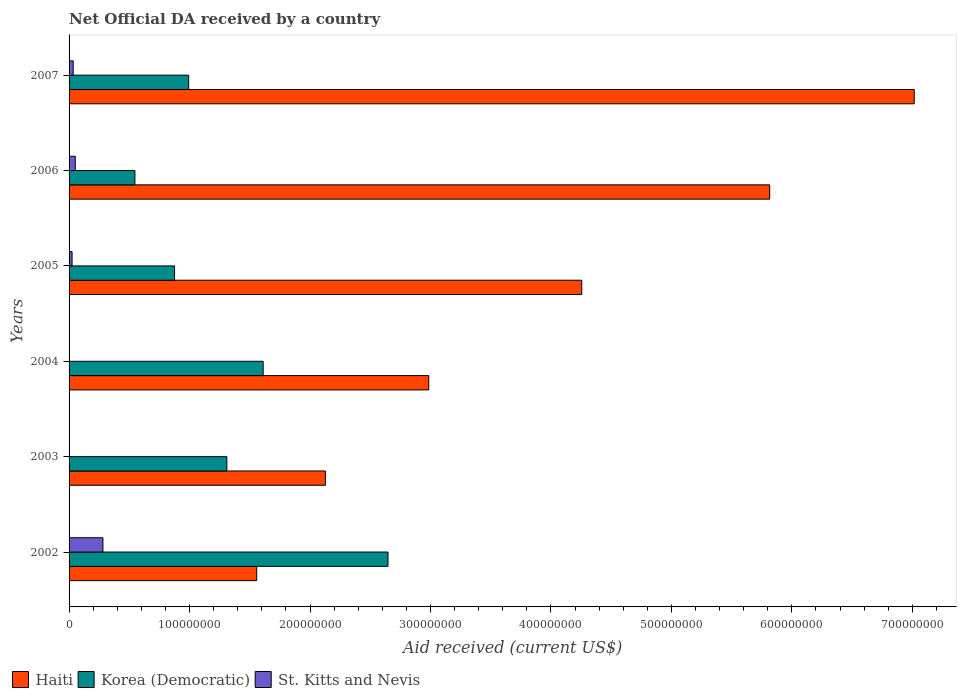How many groups of bars are there?
Your answer should be compact. 6. Are the number of bars per tick equal to the number of legend labels?
Provide a short and direct response. Yes. How many bars are there on the 5th tick from the top?
Provide a short and direct response. 3. What is the label of the 2nd group of bars from the top?
Make the answer very short. 2006. In how many cases, is the number of bars for a given year not equal to the number of legend labels?
Ensure brevity in your answer.  0. What is the net official development assistance aid received in Korea (Democratic) in 2003?
Make the answer very short. 1.31e+08. Across all years, what is the maximum net official development assistance aid received in Haiti?
Your answer should be very brief. 7.02e+08. Across all years, what is the minimum net official development assistance aid received in Korea (Democratic)?
Offer a very short reply. 5.46e+07. In which year was the net official development assistance aid received in Korea (Democratic) minimum?
Offer a very short reply. 2006. What is the total net official development assistance aid received in St. Kitts and Nevis in the graph?
Your response must be concise. 3.94e+07. What is the difference between the net official development assistance aid received in St. Kitts and Nevis in 2002 and that in 2003?
Keep it short and to the point. 2.79e+07. What is the difference between the net official development assistance aid received in Haiti in 2006 and the net official development assistance aid received in St. Kitts and Nevis in 2005?
Ensure brevity in your answer.  5.79e+08. What is the average net official development assistance aid received in Korea (Democratic) per year?
Give a very brief answer. 1.33e+08. In the year 2006, what is the difference between the net official development assistance aid received in St. Kitts and Nevis and net official development assistance aid received in Korea (Democratic)?
Your response must be concise. -4.95e+07. In how many years, is the net official development assistance aid received in Haiti greater than 400000000 US$?
Your answer should be very brief. 3. What is the ratio of the net official development assistance aid received in Haiti in 2002 to that in 2006?
Provide a short and direct response. 0.27. What is the difference between the highest and the second highest net official development assistance aid received in Korea (Democratic)?
Your answer should be very brief. 1.04e+08. What is the difference between the highest and the lowest net official development assistance aid received in Haiti?
Your answer should be very brief. 5.46e+08. What does the 2nd bar from the top in 2007 represents?
Give a very brief answer. Korea (Democratic). What does the 1st bar from the bottom in 2007 represents?
Your answer should be very brief. Haiti. Is it the case that in every year, the sum of the net official development assistance aid received in St. Kitts and Nevis and net official development assistance aid received in Haiti is greater than the net official development assistance aid received in Korea (Democratic)?
Offer a terse response. No. What is the difference between two consecutive major ticks on the X-axis?
Give a very brief answer. 1.00e+08. Are the values on the major ticks of X-axis written in scientific E-notation?
Ensure brevity in your answer.  No. Where does the legend appear in the graph?
Offer a terse response. Bottom left. What is the title of the graph?
Your response must be concise. Net Official DA received by a country. Does "Burundi" appear as one of the legend labels in the graph?
Your answer should be compact. No. What is the label or title of the X-axis?
Offer a terse response. Aid received (current US$). What is the label or title of the Y-axis?
Make the answer very short. Years. What is the Aid received (current US$) of Haiti in 2002?
Offer a terse response. 1.56e+08. What is the Aid received (current US$) of Korea (Democratic) in 2002?
Provide a succinct answer. 2.65e+08. What is the Aid received (current US$) of St. Kitts and Nevis in 2002?
Provide a short and direct response. 2.81e+07. What is the Aid received (current US$) in Haiti in 2003?
Provide a succinct answer. 2.13e+08. What is the Aid received (current US$) of Korea (Democratic) in 2003?
Your response must be concise. 1.31e+08. What is the Aid received (current US$) of Haiti in 2004?
Ensure brevity in your answer.  2.99e+08. What is the Aid received (current US$) in Korea (Democratic) in 2004?
Provide a short and direct response. 1.61e+08. What is the Aid received (current US$) in Haiti in 2005?
Your answer should be very brief. 4.26e+08. What is the Aid received (current US$) in Korea (Democratic) in 2005?
Make the answer very short. 8.76e+07. What is the Aid received (current US$) in St. Kitts and Nevis in 2005?
Provide a short and direct response. 2.50e+06. What is the Aid received (current US$) in Haiti in 2006?
Your answer should be compact. 5.82e+08. What is the Aid received (current US$) of Korea (Democratic) in 2006?
Give a very brief answer. 5.46e+07. What is the Aid received (current US$) in St. Kitts and Nevis in 2006?
Your response must be concise. 5.16e+06. What is the Aid received (current US$) in Haiti in 2007?
Keep it short and to the point. 7.02e+08. What is the Aid received (current US$) of Korea (Democratic) in 2007?
Offer a very short reply. 9.93e+07. What is the Aid received (current US$) in St. Kitts and Nevis in 2007?
Make the answer very short. 3.44e+06. Across all years, what is the maximum Aid received (current US$) of Haiti?
Your answer should be compact. 7.02e+08. Across all years, what is the maximum Aid received (current US$) in Korea (Democratic)?
Keep it short and to the point. 2.65e+08. Across all years, what is the maximum Aid received (current US$) of St. Kitts and Nevis?
Provide a short and direct response. 2.81e+07. Across all years, what is the minimum Aid received (current US$) in Haiti?
Give a very brief answer. 1.56e+08. Across all years, what is the minimum Aid received (current US$) in Korea (Democratic)?
Offer a very short reply. 5.46e+07. Across all years, what is the minimum Aid received (current US$) in St. Kitts and Nevis?
Give a very brief answer. 4.00e+04. What is the total Aid received (current US$) in Haiti in the graph?
Provide a short and direct response. 2.38e+09. What is the total Aid received (current US$) of Korea (Democratic) in the graph?
Provide a short and direct response. 7.98e+08. What is the total Aid received (current US$) in St. Kitts and Nevis in the graph?
Ensure brevity in your answer.  3.94e+07. What is the difference between the Aid received (current US$) in Haiti in 2002 and that in 2003?
Your answer should be compact. -5.70e+07. What is the difference between the Aid received (current US$) of Korea (Democratic) in 2002 and that in 2003?
Give a very brief answer. 1.34e+08. What is the difference between the Aid received (current US$) of St. Kitts and Nevis in 2002 and that in 2003?
Offer a very short reply. 2.79e+07. What is the difference between the Aid received (current US$) in Haiti in 2002 and that in 2004?
Your response must be concise. -1.43e+08. What is the difference between the Aid received (current US$) in Korea (Democratic) in 2002 and that in 2004?
Make the answer very short. 1.04e+08. What is the difference between the Aid received (current US$) of St. Kitts and Nevis in 2002 and that in 2004?
Your response must be concise. 2.81e+07. What is the difference between the Aid received (current US$) of Haiti in 2002 and that in 2005?
Provide a succinct answer. -2.70e+08. What is the difference between the Aid received (current US$) of Korea (Democratic) in 2002 and that in 2005?
Provide a succinct answer. 1.77e+08. What is the difference between the Aid received (current US$) in St. Kitts and Nevis in 2002 and that in 2005?
Ensure brevity in your answer.  2.56e+07. What is the difference between the Aid received (current US$) in Haiti in 2002 and that in 2006?
Make the answer very short. -4.26e+08. What is the difference between the Aid received (current US$) of Korea (Democratic) in 2002 and that in 2006?
Provide a short and direct response. 2.10e+08. What is the difference between the Aid received (current US$) in St. Kitts and Nevis in 2002 and that in 2006?
Your answer should be compact. 2.29e+07. What is the difference between the Aid received (current US$) in Haiti in 2002 and that in 2007?
Keep it short and to the point. -5.46e+08. What is the difference between the Aid received (current US$) of Korea (Democratic) in 2002 and that in 2007?
Make the answer very short. 1.65e+08. What is the difference between the Aid received (current US$) of St. Kitts and Nevis in 2002 and that in 2007?
Provide a succinct answer. 2.47e+07. What is the difference between the Aid received (current US$) of Haiti in 2003 and that in 2004?
Your answer should be very brief. -8.58e+07. What is the difference between the Aid received (current US$) of Korea (Democratic) in 2003 and that in 2004?
Your answer should be compact. -3.01e+07. What is the difference between the Aid received (current US$) of St. Kitts and Nevis in 2003 and that in 2004?
Provide a short and direct response. 1.20e+05. What is the difference between the Aid received (current US$) in Haiti in 2003 and that in 2005?
Offer a terse response. -2.13e+08. What is the difference between the Aid received (current US$) of Korea (Democratic) in 2003 and that in 2005?
Your answer should be very brief. 4.34e+07. What is the difference between the Aid received (current US$) in St. Kitts and Nevis in 2003 and that in 2005?
Ensure brevity in your answer.  -2.34e+06. What is the difference between the Aid received (current US$) in Haiti in 2003 and that in 2006?
Give a very brief answer. -3.69e+08. What is the difference between the Aid received (current US$) of Korea (Democratic) in 2003 and that in 2006?
Ensure brevity in your answer.  7.63e+07. What is the difference between the Aid received (current US$) of St. Kitts and Nevis in 2003 and that in 2006?
Offer a very short reply. -5.00e+06. What is the difference between the Aid received (current US$) of Haiti in 2003 and that in 2007?
Provide a succinct answer. -4.89e+08. What is the difference between the Aid received (current US$) of Korea (Democratic) in 2003 and that in 2007?
Offer a terse response. 3.17e+07. What is the difference between the Aid received (current US$) in St. Kitts and Nevis in 2003 and that in 2007?
Give a very brief answer. -3.28e+06. What is the difference between the Aid received (current US$) of Haiti in 2004 and that in 2005?
Provide a succinct answer. -1.27e+08. What is the difference between the Aid received (current US$) in Korea (Democratic) in 2004 and that in 2005?
Offer a terse response. 7.36e+07. What is the difference between the Aid received (current US$) in St. Kitts and Nevis in 2004 and that in 2005?
Ensure brevity in your answer.  -2.46e+06. What is the difference between the Aid received (current US$) in Haiti in 2004 and that in 2006?
Ensure brevity in your answer.  -2.83e+08. What is the difference between the Aid received (current US$) of Korea (Democratic) in 2004 and that in 2006?
Provide a succinct answer. 1.06e+08. What is the difference between the Aid received (current US$) of St. Kitts and Nevis in 2004 and that in 2006?
Your answer should be compact. -5.12e+06. What is the difference between the Aid received (current US$) of Haiti in 2004 and that in 2007?
Keep it short and to the point. -4.03e+08. What is the difference between the Aid received (current US$) of Korea (Democratic) in 2004 and that in 2007?
Your response must be concise. 6.18e+07. What is the difference between the Aid received (current US$) of St. Kitts and Nevis in 2004 and that in 2007?
Your answer should be compact. -3.40e+06. What is the difference between the Aid received (current US$) in Haiti in 2005 and that in 2006?
Ensure brevity in your answer.  -1.56e+08. What is the difference between the Aid received (current US$) of Korea (Democratic) in 2005 and that in 2006?
Ensure brevity in your answer.  3.29e+07. What is the difference between the Aid received (current US$) of St. Kitts and Nevis in 2005 and that in 2006?
Your response must be concise. -2.66e+06. What is the difference between the Aid received (current US$) of Haiti in 2005 and that in 2007?
Ensure brevity in your answer.  -2.76e+08. What is the difference between the Aid received (current US$) in Korea (Democratic) in 2005 and that in 2007?
Provide a short and direct response. -1.17e+07. What is the difference between the Aid received (current US$) in St. Kitts and Nevis in 2005 and that in 2007?
Offer a terse response. -9.40e+05. What is the difference between the Aid received (current US$) of Haiti in 2006 and that in 2007?
Offer a very short reply. -1.20e+08. What is the difference between the Aid received (current US$) of Korea (Democratic) in 2006 and that in 2007?
Give a very brief answer. -4.46e+07. What is the difference between the Aid received (current US$) in St. Kitts and Nevis in 2006 and that in 2007?
Make the answer very short. 1.72e+06. What is the difference between the Aid received (current US$) of Haiti in 2002 and the Aid received (current US$) of Korea (Democratic) in 2003?
Offer a terse response. 2.48e+07. What is the difference between the Aid received (current US$) in Haiti in 2002 and the Aid received (current US$) in St. Kitts and Nevis in 2003?
Your answer should be compact. 1.56e+08. What is the difference between the Aid received (current US$) in Korea (Democratic) in 2002 and the Aid received (current US$) in St. Kitts and Nevis in 2003?
Your answer should be compact. 2.65e+08. What is the difference between the Aid received (current US$) in Haiti in 2002 and the Aid received (current US$) in Korea (Democratic) in 2004?
Your answer should be very brief. -5.36e+06. What is the difference between the Aid received (current US$) in Haiti in 2002 and the Aid received (current US$) in St. Kitts and Nevis in 2004?
Provide a short and direct response. 1.56e+08. What is the difference between the Aid received (current US$) of Korea (Democratic) in 2002 and the Aid received (current US$) of St. Kitts and Nevis in 2004?
Offer a terse response. 2.65e+08. What is the difference between the Aid received (current US$) in Haiti in 2002 and the Aid received (current US$) in Korea (Democratic) in 2005?
Offer a terse response. 6.82e+07. What is the difference between the Aid received (current US$) of Haiti in 2002 and the Aid received (current US$) of St. Kitts and Nevis in 2005?
Provide a succinct answer. 1.53e+08. What is the difference between the Aid received (current US$) in Korea (Democratic) in 2002 and the Aid received (current US$) in St. Kitts and Nevis in 2005?
Provide a succinct answer. 2.62e+08. What is the difference between the Aid received (current US$) in Haiti in 2002 and the Aid received (current US$) in Korea (Democratic) in 2006?
Make the answer very short. 1.01e+08. What is the difference between the Aid received (current US$) of Haiti in 2002 and the Aid received (current US$) of St. Kitts and Nevis in 2006?
Your response must be concise. 1.51e+08. What is the difference between the Aid received (current US$) of Korea (Democratic) in 2002 and the Aid received (current US$) of St. Kitts and Nevis in 2006?
Give a very brief answer. 2.60e+08. What is the difference between the Aid received (current US$) in Haiti in 2002 and the Aid received (current US$) in Korea (Democratic) in 2007?
Provide a short and direct response. 5.65e+07. What is the difference between the Aid received (current US$) in Haiti in 2002 and the Aid received (current US$) in St. Kitts and Nevis in 2007?
Your answer should be very brief. 1.52e+08. What is the difference between the Aid received (current US$) in Korea (Democratic) in 2002 and the Aid received (current US$) in St. Kitts and Nevis in 2007?
Your response must be concise. 2.61e+08. What is the difference between the Aid received (current US$) of Haiti in 2003 and the Aid received (current US$) of Korea (Democratic) in 2004?
Provide a succinct answer. 5.16e+07. What is the difference between the Aid received (current US$) of Haiti in 2003 and the Aid received (current US$) of St. Kitts and Nevis in 2004?
Offer a very short reply. 2.13e+08. What is the difference between the Aid received (current US$) in Korea (Democratic) in 2003 and the Aid received (current US$) in St. Kitts and Nevis in 2004?
Your answer should be compact. 1.31e+08. What is the difference between the Aid received (current US$) in Haiti in 2003 and the Aid received (current US$) in Korea (Democratic) in 2005?
Ensure brevity in your answer.  1.25e+08. What is the difference between the Aid received (current US$) of Haiti in 2003 and the Aid received (current US$) of St. Kitts and Nevis in 2005?
Provide a succinct answer. 2.10e+08. What is the difference between the Aid received (current US$) in Korea (Democratic) in 2003 and the Aid received (current US$) in St. Kitts and Nevis in 2005?
Keep it short and to the point. 1.28e+08. What is the difference between the Aid received (current US$) of Haiti in 2003 and the Aid received (current US$) of Korea (Democratic) in 2006?
Provide a succinct answer. 1.58e+08. What is the difference between the Aid received (current US$) of Haiti in 2003 and the Aid received (current US$) of St. Kitts and Nevis in 2006?
Offer a terse response. 2.08e+08. What is the difference between the Aid received (current US$) of Korea (Democratic) in 2003 and the Aid received (current US$) of St. Kitts and Nevis in 2006?
Your response must be concise. 1.26e+08. What is the difference between the Aid received (current US$) in Haiti in 2003 and the Aid received (current US$) in Korea (Democratic) in 2007?
Offer a terse response. 1.13e+08. What is the difference between the Aid received (current US$) of Haiti in 2003 and the Aid received (current US$) of St. Kitts and Nevis in 2007?
Ensure brevity in your answer.  2.09e+08. What is the difference between the Aid received (current US$) in Korea (Democratic) in 2003 and the Aid received (current US$) in St. Kitts and Nevis in 2007?
Your response must be concise. 1.28e+08. What is the difference between the Aid received (current US$) of Haiti in 2004 and the Aid received (current US$) of Korea (Democratic) in 2005?
Provide a succinct answer. 2.11e+08. What is the difference between the Aid received (current US$) in Haiti in 2004 and the Aid received (current US$) in St. Kitts and Nevis in 2005?
Provide a short and direct response. 2.96e+08. What is the difference between the Aid received (current US$) of Korea (Democratic) in 2004 and the Aid received (current US$) of St. Kitts and Nevis in 2005?
Give a very brief answer. 1.59e+08. What is the difference between the Aid received (current US$) in Haiti in 2004 and the Aid received (current US$) in Korea (Democratic) in 2006?
Give a very brief answer. 2.44e+08. What is the difference between the Aid received (current US$) in Haiti in 2004 and the Aid received (current US$) in St. Kitts and Nevis in 2006?
Provide a short and direct response. 2.93e+08. What is the difference between the Aid received (current US$) of Korea (Democratic) in 2004 and the Aid received (current US$) of St. Kitts and Nevis in 2006?
Your answer should be compact. 1.56e+08. What is the difference between the Aid received (current US$) in Haiti in 2004 and the Aid received (current US$) in Korea (Democratic) in 2007?
Your answer should be compact. 1.99e+08. What is the difference between the Aid received (current US$) in Haiti in 2004 and the Aid received (current US$) in St. Kitts and Nevis in 2007?
Provide a succinct answer. 2.95e+08. What is the difference between the Aid received (current US$) of Korea (Democratic) in 2004 and the Aid received (current US$) of St. Kitts and Nevis in 2007?
Provide a short and direct response. 1.58e+08. What is the difference between the Aid received (current US$) of Haiti in 2005 and the Aid received (current US$) of Korea (Democratic) in 2006?
Offer a terse response. 3.71e+08. What is the difference between the Aid received (current US$) of Haiti in 2005 and the Aid received (current US$) of St. Kitts and Nevis in 2006?
Your answer should be very brief. 4.20e+08. What is the difference between the Aid received (current US$) of Korea (Democratic) in 2005 and the Aid received (current US$) of St. Kitts and Nevis in 2006?
Make the answer very short. 8.24e+07. What is the difference between the Aid received (current US$) in Haiti in 2005 and the Aid received (current US$) in Korea (Democratic) in 2007?
Your answer should be compact. 3.26e+08. What is the difference between the Aid received (current US$) of Haiti in 2005 and the Aid received (current US$) of St. Kitts and Nevis in 2007?
Keep it short and to the point. 4.22e+08. What is the difference between the Aid received (current US$) of Korea (Democratic) in 2005 and the Aid received (current US$) of St. Kitts and Nevis in 2007?
Offer a terse response. 8.41e+07. What is the difference between the Aid received (current US$) of Haiti in 2006 and the Aid received (current US$) of Korea (Democratic) in 2007?
Provide a succinct answer. 4.82e+08. What is the difference between the Aid received (current US$) in Haiti in 2006 and the Aid received (current US$) in St. Kitts and Nevis in 2007?
Ensure brevity in your answer.  5.78e+08. What is the difference between the Aid received (current US$) of Korea (Democratic) in 2006 and the Aid received (current US$) of St. Kitts and Nevis in 2007?
Ensure brevity in your answer.  5.12e+07. What is the average Aid received (current US$) of Haiti per year?
Give a very brief answer. 3.96e+08. What is the average Aid received (current US$) in Korea (Democratic) per year?
Offer a very short reply. 1.33e+08. What is the average Aid received (current US$) in St. Kitts and Nevis per year?
Keep it short and to the point. 6.57e+06. In the year 2002, what is the difference between the Aid received (current US$) in Haiti and Aid received (current US$) in Korea (Democratic)?
Give a very brief answer. -1.09e+08. In the year 2002, what is the difference between the Aid received (current US$) in Haiti and Aid received (current US$) in St. Kitts and Nevis?
Make the answer very short. 1.28e+08. In the year 2002, what is the difference between the Aid received (current US$) in Korea (Democratic) and Aid received (current US$) in St. Kitts and Nevis?
Provide a succinct answer. 2.37e+08. In the year 2003, what is the difference between the Aid received (current US$) of Haiti and Aid received (current US$) of Korea (Democratic)?
Give a very brief answer. 8.18e+07. In the year 2003, what is the difference between the Aid received (current US$) of Haiti and Aid received (current US$) of St. Kitts and Nevis?
Keep it short and to the point. 2.13e+08. In the year 2003, what is the difference between the Aid received (current US$) of Korea (Democratic) and Aid received (current US$) of St. Kitts and Nevis?
Give a very brief answer. 1.31e+08. In the year 2004, what is the difference between the Aid received (current US$) of Haiti and Aid received (current US$) of Korea (Democratic)?
Provide a short and direct response. 1.37e+08. In the year 2004, what is the difference between the Aid received (current US$) in Haiti and Aid received (current US$) in St. Kitts and Nevis?
Make the answer very short. 2.99e+08. In the year 2004, what is the difference between the Aid received (current US$) of Korea (Democratic) and Aid received (current US$) of St. Kitts and Nevis?
Ensure brevity in your answer.  1.61e+08. In the year 2005, what is the difference between the Aid received (current US$) in Haiti and Aid received (current US$) in Korea (Democratic)?
Make the answer very short. 3.38e+08. In the year 2005, what is the difference between the Aid received (current US$) in Haiti and Aid received (current US$) in St. Kitts and Nevis?
Make the answer very short. 4.23e+08. In the year 2005, what is the difference between the Aid received (current US$) of Korea (Democratic) and Aid received (current US$) of St. Kitts and Nevis?
Your answer should be very brief. 8.51e+07. In the year 2006, what is the difference between the Aid received (current US$) of Haiti and Aid received (current US$) of Korea (Democratic)?
Give a very brief answer. 5.27e+08. In the year 2006, what is the difference between the Aid received (current US$) in Haiti and Aid received (current US$) in St. Kitts and Nevis?
Provide a short and direct response. 5.76e+08. In the year 2006, what is the difference between the Aid received (current US$) of Korea (Democratic) and Aid received (current US$) of St. Kitts and Nevis?
Give a very brief answer. 4.95e+07. In the year 2007, what is the difference between the Aid received (current US$) in Haiti and Aid received (current US$) in Korea (Democratic)?
Keep it short and to the point. 6.02e+08. In the year 2007, what is the difference between the Aid received (current US$) in Haiti and Aid received (current US$) in St. Kitts and Nevis?
Keep it short and to the point. 6.98e+08. In the year 2007, what is the difference between the Aid received (current US$) of Korea (Democratic) and Aid received (current US$) of St. Kitts and Nevis?
Give a very brief answer. 9.58e+07. What is the ratio of the Aid received (current US$) in Haiti in 2002 to that in 2003?
Your response must be concise. 0.73. What is the ratio of the Aid received (current US$) of Korea (Democratic) in 2002 to that in 2003?
Provide a short and direct response. 2.02. What is the ratio of the Aid received (current US$) in St. Kitts and Nevis in 2002 to that in 2003?
Offer a terse response. 175.62. What is the ratio of the Aid received (current US$) of Haiti in 2002 to that in 2004?
Offer a terse response. 0.52. What is the ratio of the Aid received (current US$) of Korea (Democratic) in 2002 to that in 2004?
Keep it short and to the point. 1.64. What is the ratio of the Aid received (current US$) of St. Kitts and Nevis in 2002 to that in 2004?
Make the answer very short. 702.5. What is the ratio of the Aid received (current US$) of Haiti in 2002 to that in 2005?
Your answer should be compact. 0.37. What is the ratio of the Aid received (current US$) of Korea (Democratic) in 2002 to that in 2005?
Give a very brief answer. 3.02. What is the ratio of the Aid received (current US$) of St. Kitts and Nevis in 2002 to that in 2005?
Offer a terse response. 11.24. What is the ratio of the Aid received (current US$) in Haiti in 2002 to that in 2006?
Your answer should be compact. 0.27. What is the ratio of the Aid received (current US$) of Korea (Democratic) in 2002 to that in 2006?
Ensure brevity in your answer.  4.84. What is the ratio of the Aid received (current US$) in St. Kitts and Nevis in 2002 to that in 2006?
Offer a very short reply. 5.45. What is the ratio of the Aid received (current US$) of Haiti in 2002 to that in 2007?
Give a very brief answer. 0.22. What is the ratio of the Aid received (current US$) in Korea (Democratic) in 2002 to that in 2007?
Make the answer very short. 2.67. What is the ratio of the Aid received (current US$) in St. Kitts and Nevis in 2002 to that in 2007?
Keep it short and to the point. 8.17. What is the ratio of the Aid received (current US$) of Haiti in 2003 to that in 2004?
Your response must be concise. 0.71. What is the ratio of the Aid received (current US$) in Korea (Democratic) in 2003 to that in 2004?
Your response must be concise. 0.81. What is the ratio of the Aid received (current US$) of Haiti in 2003 to that in 2005?
Make the answer very short. 0.5. What is the ratio of the Aid received (current US$) of Korea (Democratic) in 2003 to that in 2005?
Provide a succinct answer. 1.5. What is the ratio of the Aid received (current US$) in St. Kitts and Nevis in 2003 to that in 2005?
Offer a terse response. 0.06. What is the ratio of the Aid received (current US$) of Haiti in 2003 to that in 2006?
Your answer should be compact. 0.37. What is the ratio of the Aid received (current US$) of Korea (Democratic) in 2003 to that in 2006?
Make the answer very short. 2.4. What is the ratio of the Aid received (current US$) in St. Kitts and Nevis in 2003 to that in 2006?
Your response must be concise. 0.03. What is the ratio of the Aid received (current US$) of Haiti in 2003 to that in 2007?
Offer a very short reply. 0.3. What is the ratio of the Aid received (current US$) of Korea (Democratic) in 2003 to that in 2007?
Your answer should be compact. 1.32. What is the ratio of the Aid received (current US$) of St. Kitts and Nevis in 2003 to that in 2007?
Offer a very short reply. 0.05. What is the ratio of the Aid received (current US$) in Haiti in 2004 to that in 2005?
Your answer should be compact. 0.7. What is the ratio of the Aid received (current US$) of Korea (Democratic) in 2004 to that in 2005?
Your answer should be very brief. 1.84. What is the ratio of the Aid received (current US$) of St. Kitts and Nevis in 2004 to that in 2005?
Provide a succinct answer. 0.02. What is the ratio of the Aid received (current US$) in Haiti in 2004 to that in 2006?
Keep it short and to the point. 0.51. What is the ratio of the Aid received (current US$) of Korea (Democratic) in 2004 to that in 2006?
Offer a very short reply. 2.95. What is the ratio of the Aid received (current US$) of St. Kitts and Nevis in 2004 to that in 2006?
Provide a short and direct response. 0.01. What is the ratio of the Aid received (current US$) in Haiti in 2004 to that in 2007?
Give a very brief answer. 0.43. What is the ratio of the Aid received (current US$) of Korea (Democratic) in 2004 to that in 2007?
Your response must be concise. 1.62. What is the ratio of the Aid received (current US$) in St. Kitts and Nevis in 2004 to that in 2007?
Your answer should be very brief. 0.01. What is the ratio of the Aid received (current US$) of Haiti in 2005 to that in 2006?
Keep it short and to the point. 0.73. What is the ratio of the Aid received (current US$) of Korea (Democratic) in 2005 to that in 2006?
Make the answer very short. 1.6. What is the ratio of the Aid received (current US$) in St. Kitts and Nevis in 2005 to that in 2006?
Provide a succinct answer. 0.48. What is the ratio of the Aid received (current US$) of Haiti in 2005 to that in 2007?
Provide a succinct answer. 0.61. What is the ratio of the Aid received (current US$) in Korea (Democratic) in 2005 to that in 2007?
Provide a short and direct response. 0.88. What is the ratio of the Aid received (current US$) of St. Kitts and Nevis in 2005 to that in 2007?
Offer a terse response. 0.73. What is the ratio of the Aid received (current US$) in Haiti in 2006 to that in 2007?
Your response must be concise. 0.83. What is the ratio of the Aid received (current US$) of Korea (Democratic) in 2006 to that in 2007?
Your answer should be very brief. 0.55. What is the ratio of the Aid received (current US$) in St. Kitts and Nevis in 2006 to that in 2007?
Provide a short and direct response. 1.5. What is the difference between the highest and the second highest Aid received (current US$) of Haiti?
Offer a terse response. 1.20e+08. What is the difference between the highest and the second highest Aid received (current US$) in Korea (Democratic)?
Your answer should be very brief. 1.04e+08. What is the difference between the highest and the second highest Aid received (current US$) of St. Kitts and Nevis?
Offer a terse response. 2.29e+07. What is the difference between the highest and the lowest Aid received (current US$) in Haiti?
Offer a terse response. 5.46e+08. What is the difference between the highest and the lowest Aid received (current US$) in Korea (Democratic)?
Your response must be concise. 2.10e+08. What is the difference between the highest and the lowest Aid received (current US$) of St. Kitts and Nevis?
Ensure brevity in your answer.  2.81e+07. 